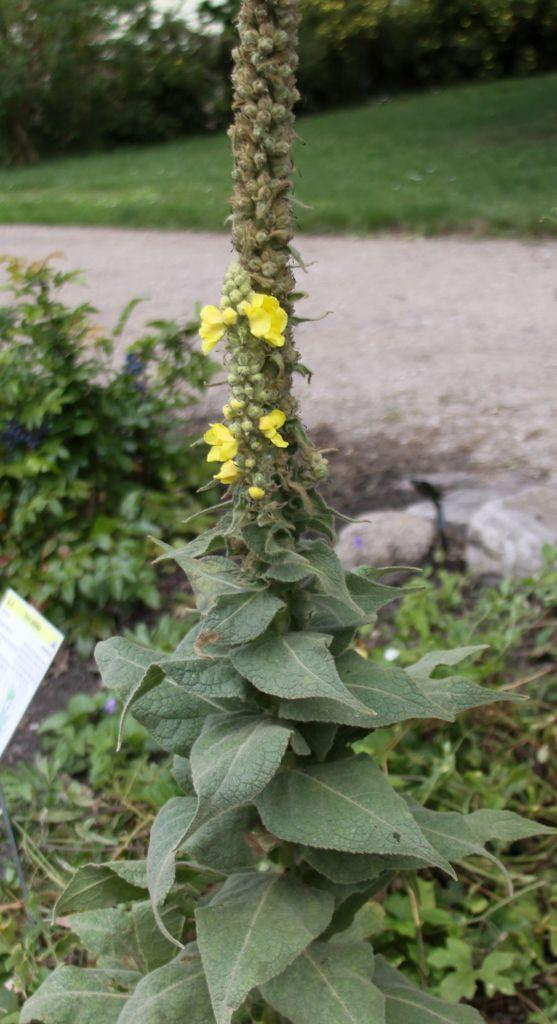What type of vegetation can be seen in the image? There are plants, grass, and flowers in the image. What other objects can be seen in the image besides vegetation? There are stones and a paper in the image. What type of crib can be seen in the image? There is no crib present in the image. What time of day is depicted in the image? The time of day cannot be determined from the image, as there are no specific clues or indicators present. 